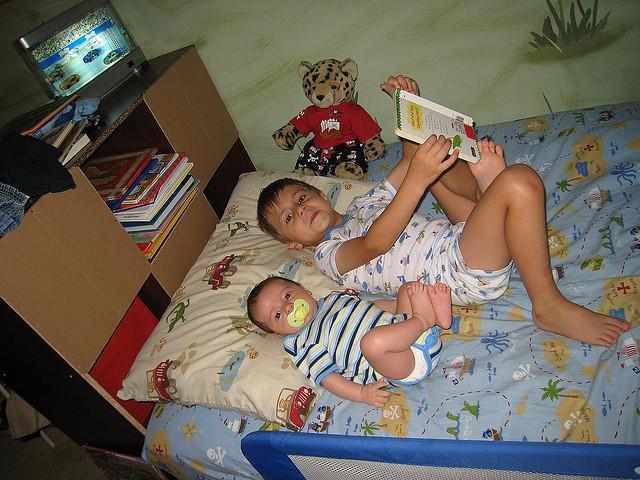How many people are there?
Give a very brief answer. 2. How many books are there?
Give a very brief answer. 2. How many cars are facing north in the picture?
Give a very brief answer. 0. 